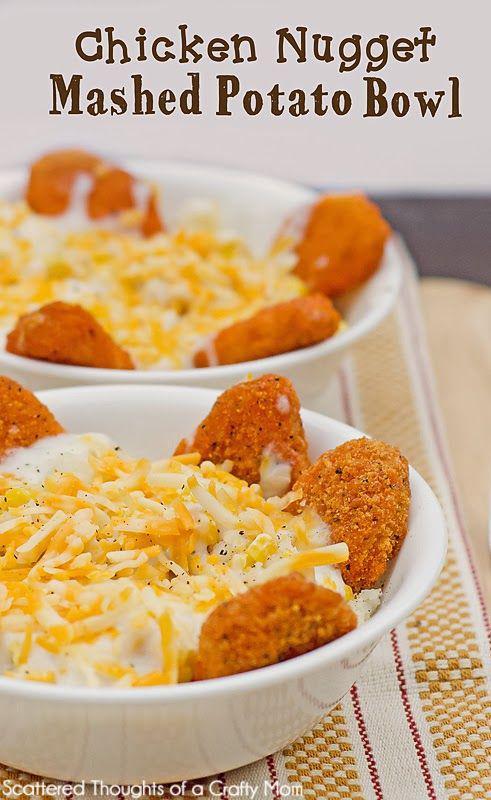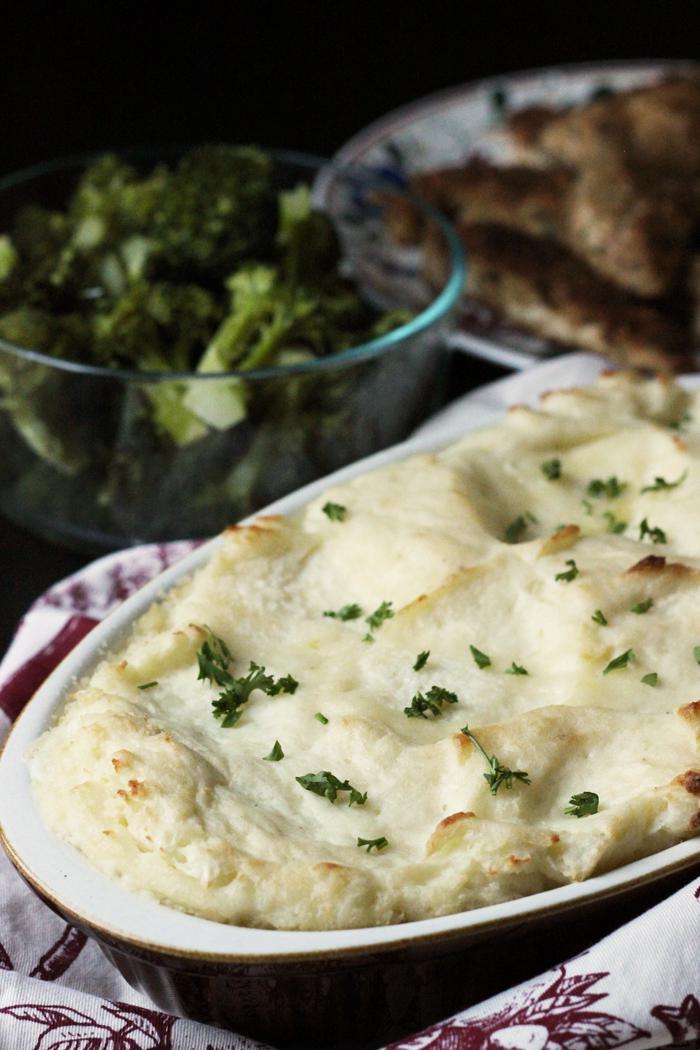The first image is the image on the left, the second image is the image on the right. Assess this claim about the two images: "At least one image in the set features a green garnish on top of the food and other dishes in the background.". Correct or not? Answer yes or no. Yes. The first image is the image on the left, the second image is the image on the right. Evaluate the accuracy of this statement regarding the images: "A silverware serving utensil is in one image with a bowl of mashed potatoes.". Is it true? Answer yes or no. No. 